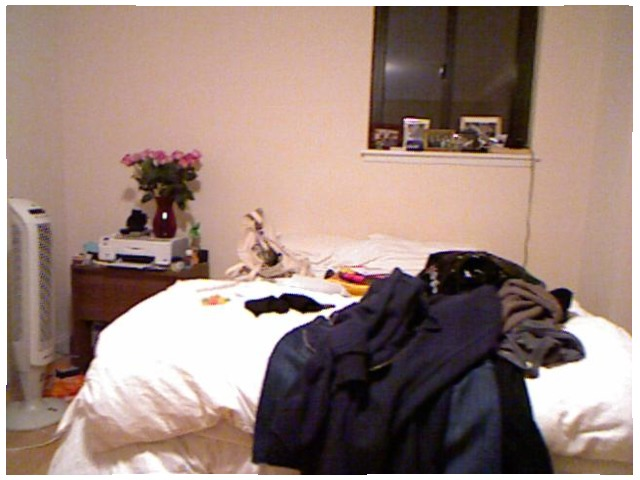<image>
Is the heater in front of the flower? Yes. The heater is positioned in front of the flower, appearing closer to the camera viewpoint. Where is the flower was in relation to the vcd? Is it in front of the vcd? No. The flower was is not in front of the vcd. The spatial positioning shows a different relationship between these objects. 